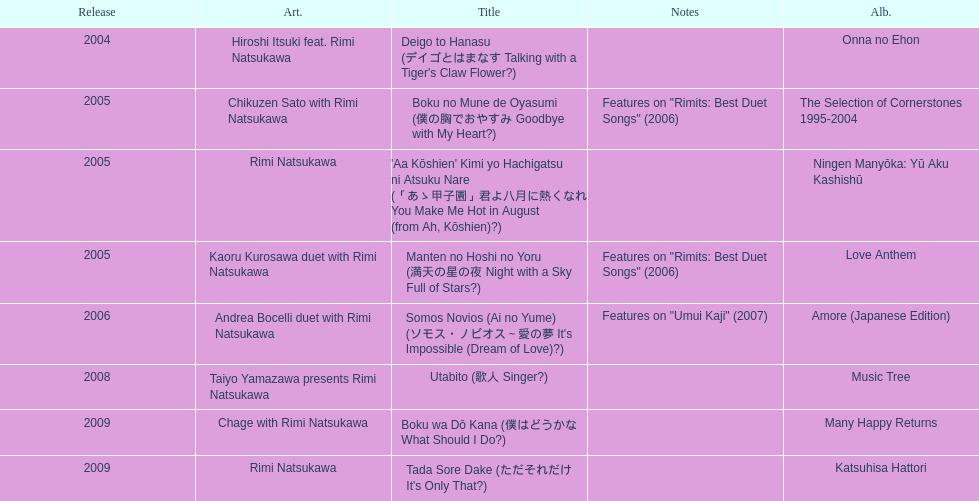Which was not released in 2004, onna no ehon or music tree? Music Tree. 